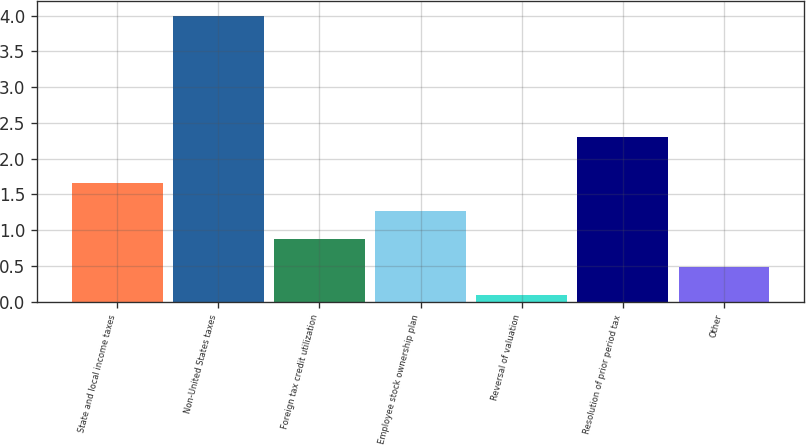<chart> <loc_0><loc_0><loc_500><loc_500><bar_chart><fcel>State and local income taxes<fcel>Non-United States taxes<fcel>Foreign tax credit utilization<fcel>Employee stock ownership plan<fcel>Reversal of valuation<fcel>Resolution of prior period tax<fcel>Other<nl><fcel>1.66<fcel>4<fcel>0.88<fcel>1.27<fcel>0.1<fcel>2.3<fcel>0.49<nl></chart> 